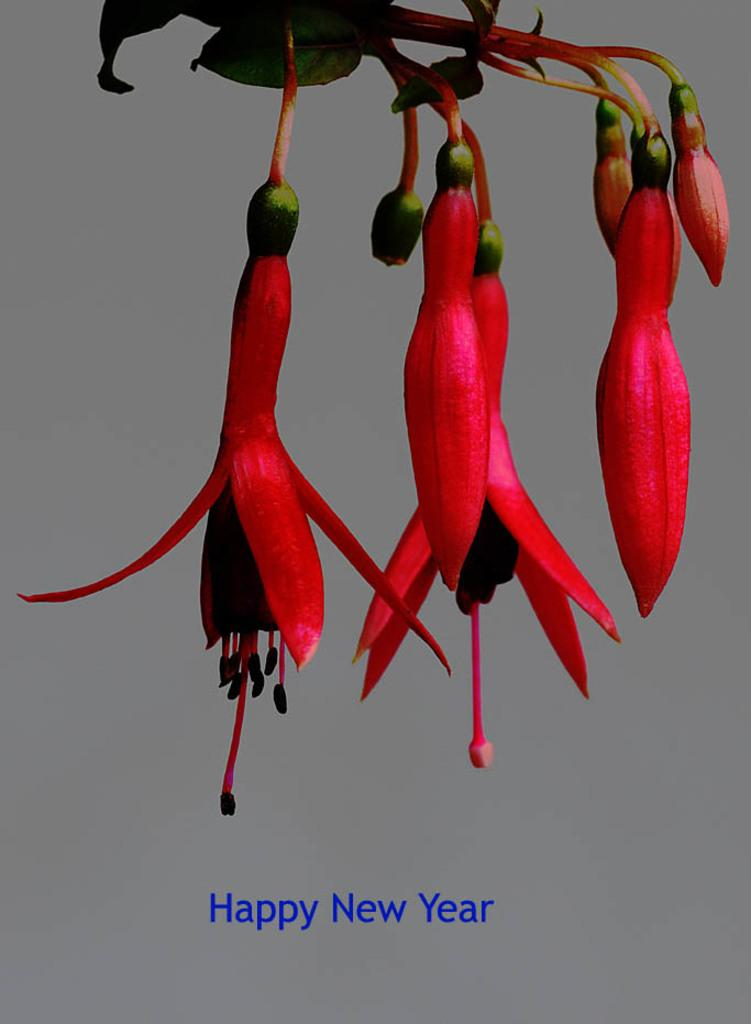What type of plant life is present in the image? There are flowers in the image. Can you describe the structure of the flowers? The flowers have stems, leaves, and buds. Where can the text be found in the image? The text is located at the bottom of the image. What type of dinner is being served in the image? There is no dinner present in the image; it features flowers with text at the bottom. How much wealth is depicted in the image? There is no indication of wealth in the image; it features flowers with text at the bottom. 